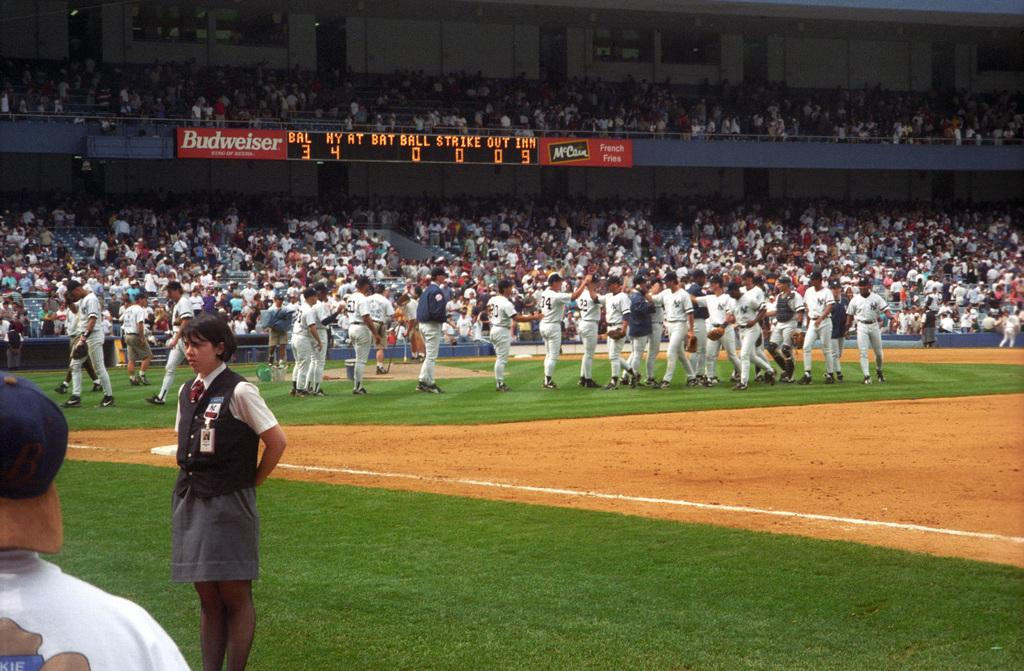<image>
Write a terse but informative summary of the picture. Baseball players are on the field that has a Budweiser sign in the background. 